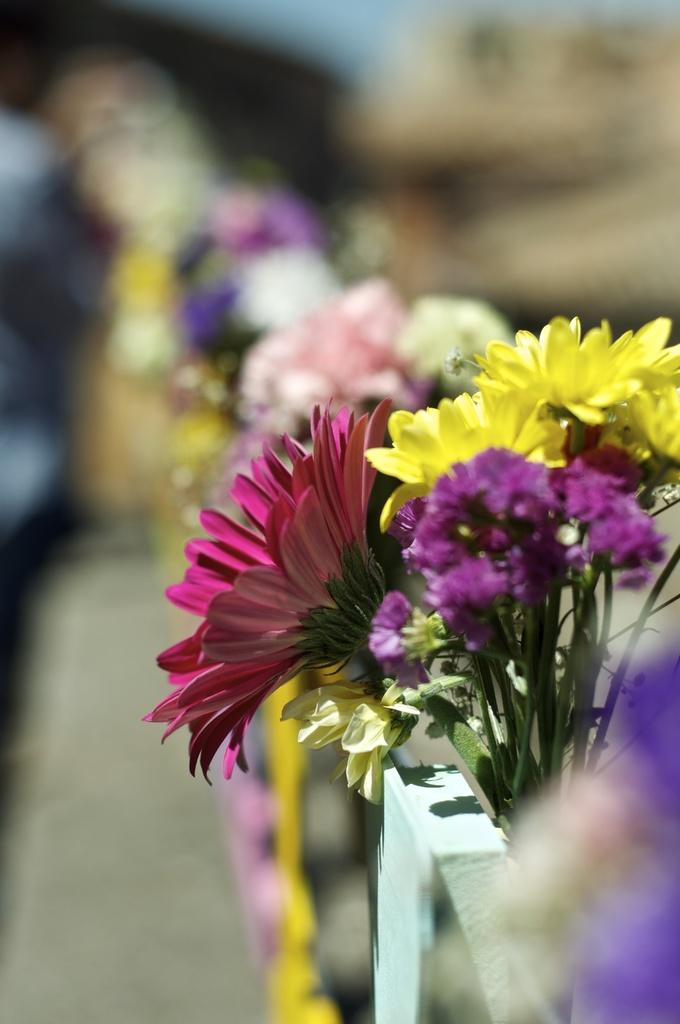What type of living organisms can be seen in the image? There are flowers in the image. Can you describe the background of the image? The background of the image is blurred. What type of alarm can be heard going off in the image? There is no alarm present in the image, as it is a still image and not a video or audio recording. What type of field is visible in the image? There is no field visible in the image; it features flowers and a blurred background. What type of nose can be seen on the flowers in the image? Flowers do not have noses, as they are plants and not animals. 